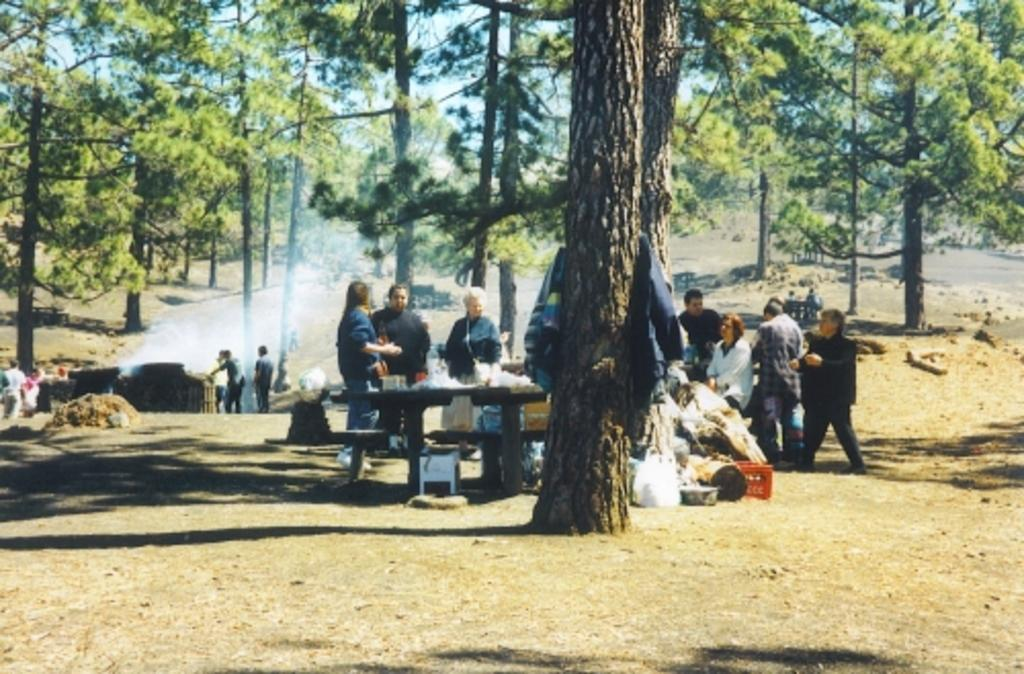What is the main piece of furniture in the image? There is a table in the image. What is on the table in the image? There are many items on the table in the image. How many people are in the image? There are many people in the image. What type of natural elements can be seen in the image? There are trees in the image. What is the unusual atmospheric condition in the image? There is smoke in the image. What is on the ground in the image? There are covers and a basket on the ground, along with many other items. What is the name of the person who brought peace to the gathering in the image? There is no indication of a specific person bringing peace to the gathering in the image, nor is there any reference to a gathering in the provided facts. 